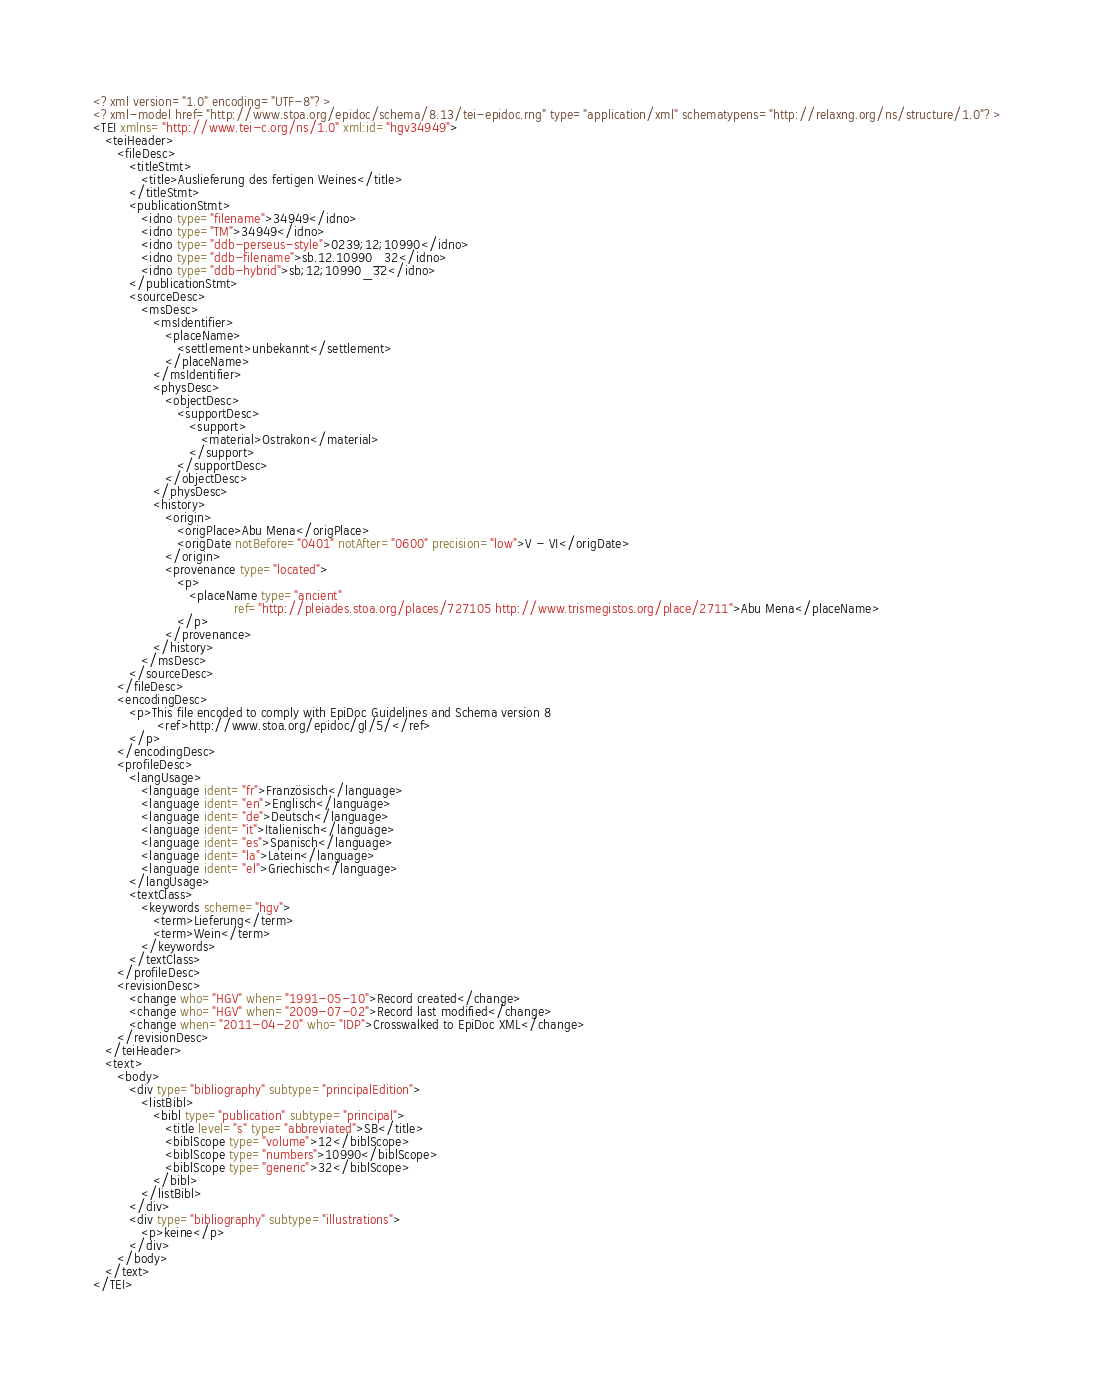<code> <loc_0><loc_0><loc_500><loc_500><_XML_><?xml version="1.0" encoding="UTF-8"?>
<?xml-model href="http://www.stoa.org/epidoc/schema/8.13/tei-epidoc.rng" type="application/xml" schematypens="http://relaxng.org/ns/structure/1.0"?>
<TEI xmlns="http://www.tei-c.org/ns/1.0" xml:id="hgv34949">
   <teiHeader>
      <fileDesc>
         <titleStmt>
            <title>Auslieferung des fertigen Weines</title>
         </titleStmt>
         <publicationStmt>
            <idno type="filename">34949</idno>
            <idno type="TM">34949</idno>
            <idno type="ddb-perseus-style">0239;12;10990</idno>
            <idno type="ddb-filename">sb.12.10990_32</idno>
            <idno type="ddb-hybrid">sb;12;10990_32</idno>
         </publicationStmt>
         <sourceDesc>
            <msDesc>
               <msIdentifier>
                  <placeName>
                     <settlement>unbekannt</settlement>
                  </placeName>
               </msIdentifier>
               <physDesc>
                  <objectDesc>
                     <supportDesc>
                        <support>
                           <material>Ostrakon</material>
                        </support>
                     </supportDesc>
                  </objectDesc>
               </physDesc>
               <history>
                  <origin>
                     <origPlace>Abu Mena</origPlace>
                     <origDate notBefore="0401" notAfter="0600" precision="low">V - VI</origDate>
                  </origin>
                  <provenance type="located">
                     <p>
                        <placeName type="ancient"
                                   ref="http://pleiades.stoa.org/places/727105 http://www.trismegistos.org/place/2711">Abu Mena</placeName>
                     </p>
                  </provenance>
               </history>
            </msDesc>
         </sourceDesc>
      </fileDesc>
      <encodingDesc>
         <p>This file encoded to comply with EpiDoc Guidelines and Schema version 8
                <ref>http://www.stoa.org/epidoc/gl/5/</ref>
         </p>
      </encodingDesc>
      <profileDesc>
         <langUsage>
            <language ident="fr">Französisch</language>
            <language ident="en">Englisch</language>
            <language ident="de">Deutsch</language>
            <language ident="it">Italienisch</language>
            <language ident="es">Spanisch</language>
            <language ident="la">Latein</language>
            <language ident="el">Griechisch</language>
         </langUsage>
         <textClass>
            <keywords scheme="hgv">
               <term>Lieferung</term>
               <term>Wein</term>
            </keywords>
         </textClass>
      </profileDesc>
      <revisionDesc>
         <change who="HGV" when="1991-05-10">Record created</change>
         <change who="HGV" when="2009-07-02">Record last modified</change>
         <change when="2011-04-20" who="IDP">Crosswalked to EpiDoc XML</change>
      </revisionDesc>
   </teiHeader>
   <text>
      <body>
         <div type="bibliography" subtype="principalEdition">
            <listBibl>
               <bibl type="publication" subtype="principal">
                  <title level="s" type="abbreviated">SB</title>
                  <biblScope type="volume">12</biblScope>
                  <biblScope type="numbers">10990</biblScope>
                  <biblScope type="generic">32</biblScope>
               </bibl>
            </listBibl>
         </div>
         <div type="bibliography" subtype="illustrations">
            <p>keine</p>
         </div>
      </body>
   </text>
</TEI>
</code> 